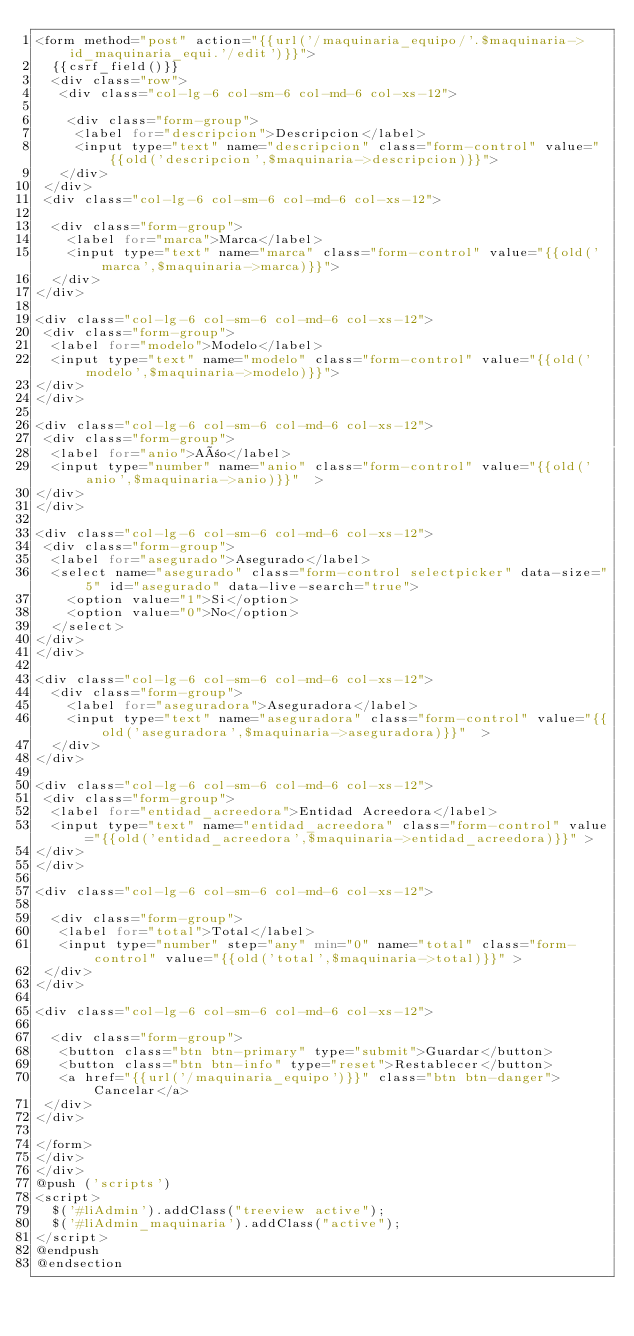<code> <loc_0><loc_0><loc_500><loc_500><_PHP_><form method="post" action="{{url('/maquinaria_equipo/'.$maquinaria->id_maquinaria_equi.'/edit')}}">
  {{csrf_field()}}
  <div class="row">  
   <div class="col-lg-6 col-sm-6 col-md-6 col-xs-12">

    <div class="form-group">
     <label for="descripcion">Descripcion</label>
     <input type="text" name="descripcion" class="form-control" value="{{old('descripcion',$maquinaria->descripcion)}}">
   </div>
 </div>
 <div class="col-lg-6 col-sm-6 col-md-6 col-xs-12">

  <div class="form-group">
    <label for="marca">Marca</label>
    <input type="text" name="marca" class="form-control" value="{{old('marca',$maquinaria->marca)}}">
  </div>
</div>

<div class="col-lg-6 col-sm-6 col-md-6 col-xs-12">
 <div class="form-group">
  <label for="modelo">Modelo</label>
  <input type="text" name="modelo" class="form-control" value="{{old('modelo',$maquinaria->modelo)}}">
</div>            
</div>            

<div class="col-lg-6 col-sm-6 col-md-6 col-xs-12">
 <div class="form-group">
  <label for="anio">Año</label>
  <input type="number" name="anio" class="form-control" value="{{old('anio',$maquinaria->anio)}}"  >
</div>            
</div>            

<div class="col-lg-6 col-sm-6 col-md-6 col-xs-12">
 <div class="form-group">
  <label for="asegurado">Asegurado</label>
  <select name="asegurado" class="form-control selectpicker" data-size="5" id="asegurado" data-live-search="true">
    <option value="1">Si</option>
    <option value="0">No</option>
  </select>
</div>
</div>

<div class="col-lg-6 col-sm-6 col-md-6 col-xs-12">            
  <div class="form-group">
    <label for="aseguradora">Aseguradora</label>
    <input type="text" name="aseguradora" class="form-control" value="{{old('aseguradora',$maquinaria->aseguradora)}}"  >
  </div>            
</div>            

<div class="col-lg-6 col-sm-6 col-md-6 col-xs-12">
 <div class="form-group">
  <label for="entidad_acreedora">Entidad Acreedora</label>
  <input type="text" name="entidad_acreedora" class="form-control" value="{{old('entidad_acreedora',$maquinaria->entidad_acreedora)}}" >
</div>
</div>

<div class="col-lg-6 col-sm-6 col-md-6 col-xs-12">

  <div class="form-group">
   <label for="total">Total</label>
   <input type="number" step="any" min="0" name="total" class="form-control" value="{{old('total',$maquinaria->total)}}" >
 </div>
</div>         

<div class="col-lg-6 col-sm-6 col-md-6 col-xs-12">

  <div class="form-group">
   <button class="btn btn-primary" type="submit">Guardar</button>
   <button class="btn btn-info" type="reset">Restablecer</button>
   <a href="{{url('/maquinaria_equipo')}}" class="btn btn-danger">Cancelar</a>
 </div>
</div>

</form>
</div>
</div>
@push ('scripts')
<script>
  $('#liAdmin').addClass("treeview active");
  $('#liAdmin_maquinaria').addClass("active");
</script>
@endpush
@endsection
</code> 